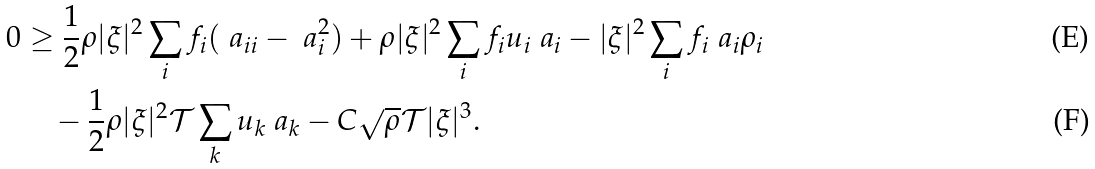<formula> <loc_0><loc_0><loc_500><loc_500>0 & \geq \frac { 1 } { 2 } \rho | \xi | ^ { 2 } \sum _ { i } f _ { i } ( \ a _ { i i } - \ a _ { i } ^ { 2 } ) + \rho | \xi | ^ { 2 } \sum _ { i } f _ { i } u _ { i } \ a _ { i } - | \xi | ^ { 2 } \sum _ { i } f _ { i } \ a _ { i } \rho _ { i } \\ & \quad - \frac { 1 } { 2 } \rho | \xi | ^ { 2 } { \mathcal { T } } \sum _ { k } u _ { k } \ a _ { k } - C \sqrt { \rho } { \mathcal { T } } | \xi | ^ { 3 } .</formula> 